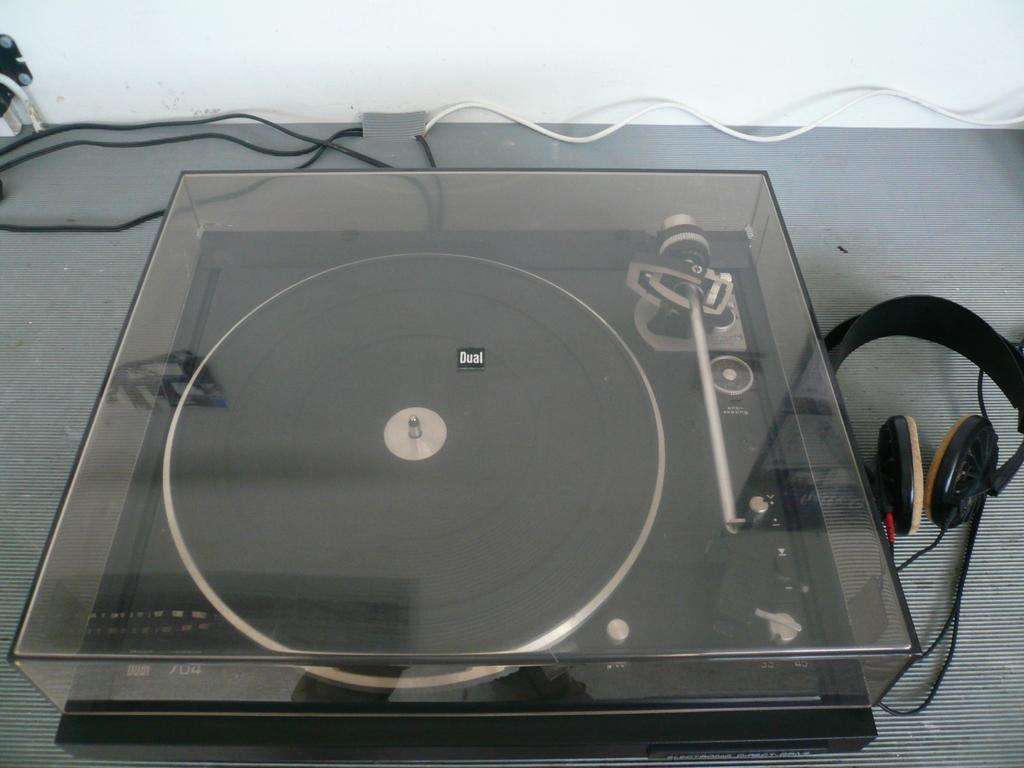What can be seen in the image that resembles a device? There is a device in the image. What are the headsets used for in the image? The headsets are used for listening in the image. What connects the device and the headsets in the image? There are wires in the image that connect the device and the headsets. What is the color of the surface in the image? The surface in the image is gray. What part of the room can be seen in the background of the image? There is a partial part of the wall visible in the background of the image. Can you see any bubbles coming out of the kettle in the image? There is no kettle present in the image, and therefore no bubbles can be seen. What type of appliance is used to create bubbles in the image? There is no appliance or bubbles present in the image. 